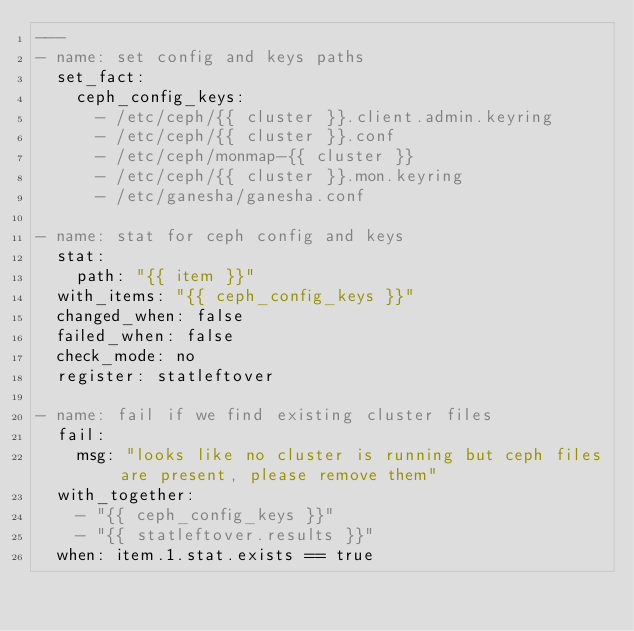Convert code to text. <code><loc_0><loc_0><loc_500><loc_500><_YAML_>---
- name: set config and keys paths
  set_fact:
    ceph_config_keys:
      - /etc/ceph/{{ cluster }}.client.admin.keyring
      - /etc/ceph/{{ cluster }}.conf
      - /etc/ceph/monmap-{{ cluster }}
      - /etc/ceph/{{ cluster }}.mon.keyring
      - /etc/ganesha/ganesha.conf

- name: stat for ceph config and keys
  stat:
    path: "{{ item }}"
  with_items: "{{ ceph_config_keys }}"
  changed_when: false
  failed_when: false
  check_mode: no
  register: statleftover

- name: fail if we find existing cluster files
  fail:
    msg: "looks like no cluster is running but ceph files are present, please remove them"
  with_together:
    - "{{ ceph_config_keys }}"
    - "{{ statleftover.results }}"
  when: item.1.stat.exists == true
</code> 